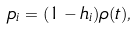Convert formula to latex. <formula><loc_0><loc_0><loc_500><loc_500>p _ { i } = ( 1 - h _ { i } ) \rho ( t ) ,</formula> 